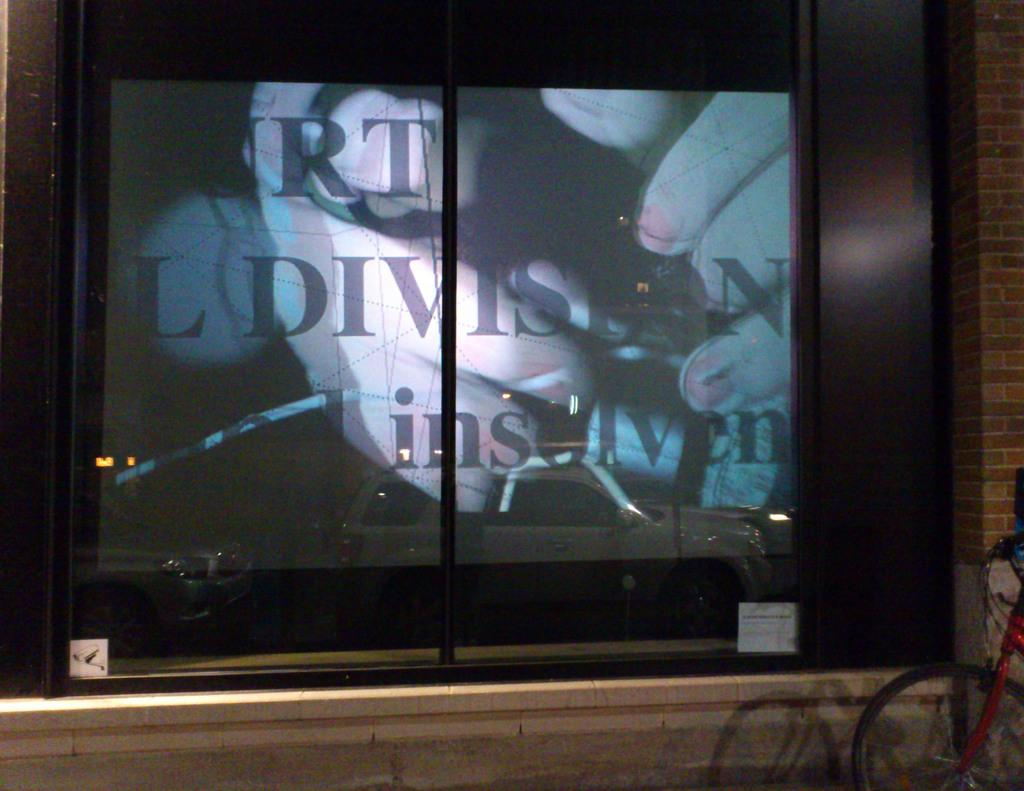<image>
Create a compact narrative representing the image presented. a screen with the letters RT on it 